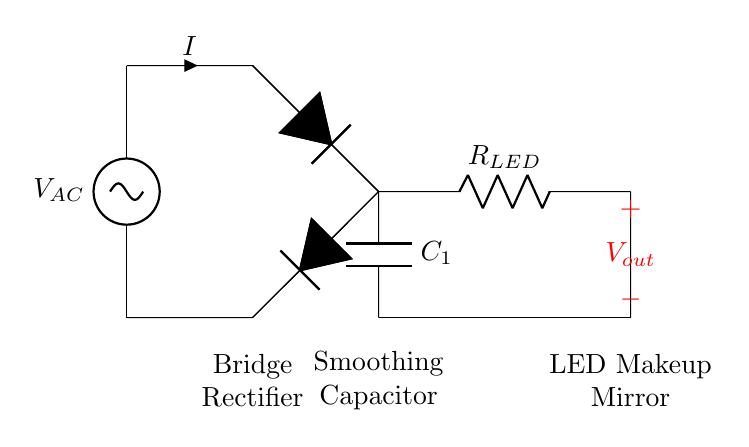What is the type of power supply in this circuit? The circuit utilizes an alternating current (AC) power supply marked as V_AC at the input.
Answer: AC What component is responsible for converting AC to DC? The component that converts alternating current (AC) to direct current (DC) is the bridge rectifier shown in the diagram, denoted by the two diodes arranged in a bridge configuration.
Answer: Bridge Rectifier What does the smoothing capacitor do in this circuit? The smoothing capacitor, labeled as C1 in the diagram, is used to reduce the ripple voltage of the rectified output, providing a more constant voltage to the load.
Answer: Reduces Ripple What is the load component in this circuit? The load component connected to the output voltage is the LED makeup mirror, indicated by the resistor labeled R_LED.
Answer: LED Makeup Mirror How many diodes are used in the bridge rectifier? The bridge rectifier includes four diodes configured to allow both halves of the AC signal to contribute to the DC output, meaning four diodes are used in this configuration.
Answer: Four What is the purpose of the resistor labeled R_LED? The resistor R_LED limits the current flowing to the LED makeup mirror to prevent damage, ensuring it operates safely within its rated specifications.
Answer: Current Limiting What is the output voltage labeled in the circuit? The output voltage is marked as V_out, which is the voltage available across the LED makeup mirror from the smoothed DC output.
Answer: V_out 